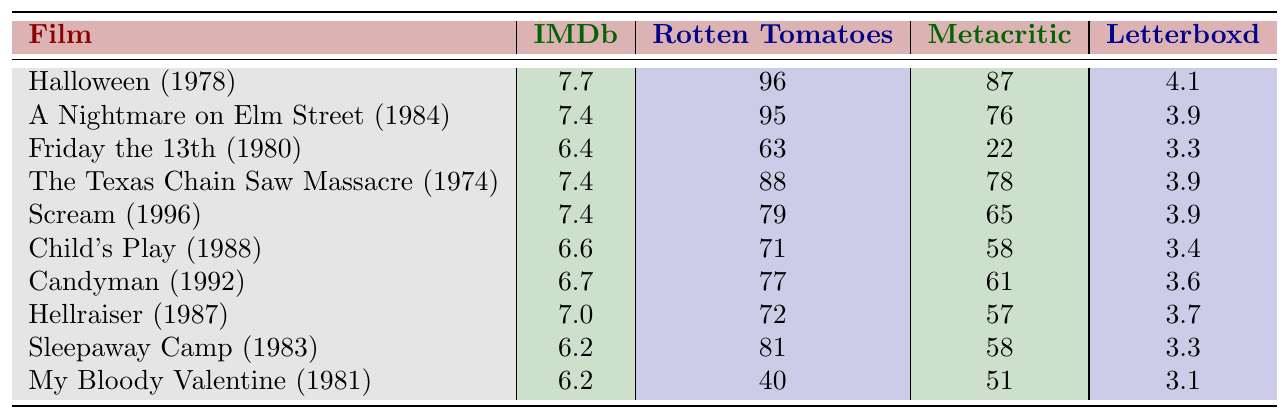What is the highest IMDb rating among the listed films? The highest IMDb rating is found by comparing all the IMDb ratings in the table. "Halloween (1978)" has the highest rating of 7.7.
Answer: 7.7 Which film has the lowest Rotten Tomatoes score? The lowest Rotten Tomatoes score can be found by looking through the Rotten Tomatoes ratings. "My Bloody Valentine (1981)" has the lowest score at 40.
Answer: 40 What is the average Metacritic score of the films? To find the average Metacritic score, sum all the Metacritic scores: (87 + 76 + 22 + 78 + 65 + 58 + 61 + 57 + 58 + 51) = 515. Then, divide by the number of films (10), yielding 515/10 = 51.5.
Answer: 51.5 Does "Scream (1996)" have a higher IMDb rating than "A Nightmare on Elm Street (1984)"? Compare the IMDb ratings: "Scream (1996)" has a rating of 7.4 and "A Nightmare on Elm Street (1984)" has 7.4 as well. They are equal.
Answer: No What is the difference in Rotten Tomatoes scores between "Candyman (1992)" and "Sleepaway Camp (1983)"? The Rotten Tomatoes score for "Candyman (1992)" is 77 and for "Sleepaway Camp (1983)" is 81. The difference is 81 - 77 = 4.
Answer: 4 Which film received a better score on Letterboxd, "Hellraiser (1987)" or "Child's Play (1988)"? "Hellraiser (1987)" has a Letterboxd score of 3.7, while "Child's Play (1988)" has a score of 3.4. Since 3.7 is greater than 3.4, "Hellraiser" is rated better.
Answer: Hellraiser (1987) What is the median IMDb score of the films listed? To find the median, we must first list the IMDb scores in ascending order: 6.2, 6.2, 6.4, 6.6, 7.0, 7.4, 7.4, 7.4, 7.7. As there are 10 values, the median is the average of the 5th (7.0) and 6th (7.4) scores: (7.0 + 7.4)/2 = 7.2.
Answer: 7.2 Which film has the highest difference between Rotten Tomatoes and Metacritic scores? We calculate the difference between Rotten Tomatoes and Metacritic scores for each film. The largest difference occurs with "Friday the 13th (1980)", where the difference is 63 - 22 = 41.
Answer: 41 Is the Letterboxd score for "Halloween (1978)" higher than 4.0? The Letterboxd score for "Halloween (1978)" is 4.1. Since 4.1 is higher than 4.0, the statement is true.
Answer: Yes What is the total of all Rotten Tomatoes scores? To find the total, we add all Rotten Tomatoes scores: 96 + 95 + 63 + 88 + 79 + 71 + 77 + 72 + 81 + 40 = 792.
Answer: 792 